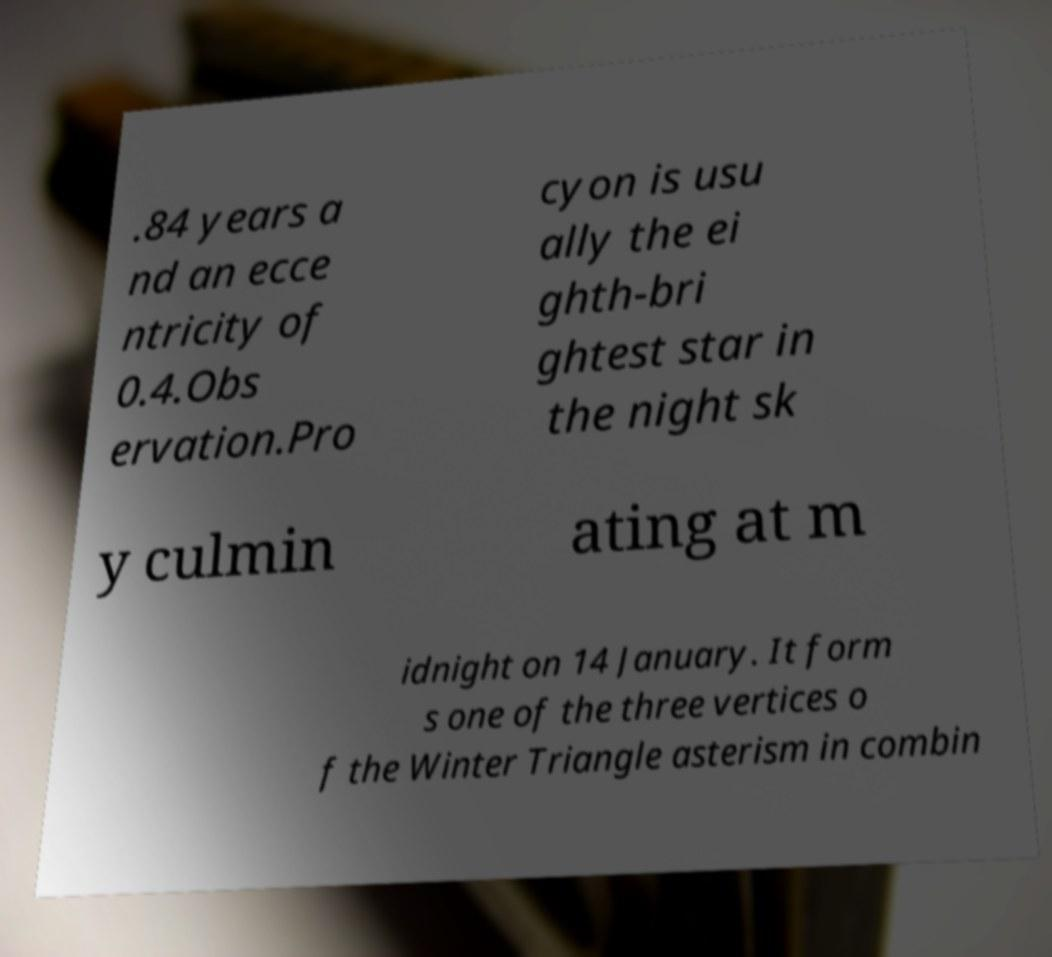Could you extract and type out the text from this image? .84 years a nd an ecce ntricity of 0.4.Obs ervation.Pro cyon is usu ally the ei ghth-bri ghtest star in the night sk y culmin ating at m idnight on 14 January. It form s one of the three vertices o f the Winter Triangle asterism in combin 